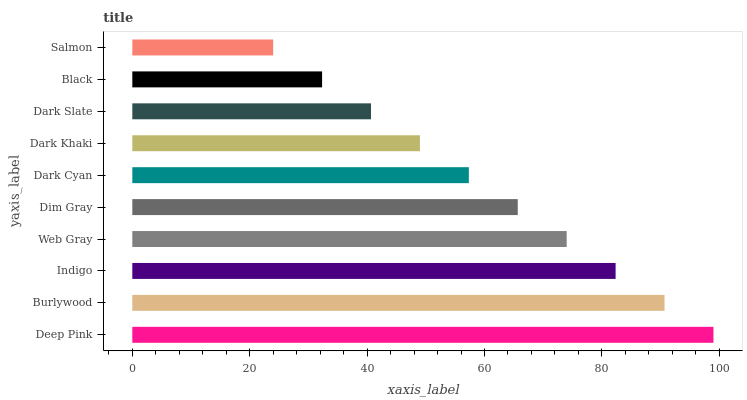Is Salmon the minimum?
Answer yes or no. Yes. Is Deep Pink the maximum?
Answer yes or no. Yes. Is Burlywood the minimum?
Answer yes or no. No. Is Burlywood the maximum?
Answer yes or no. No. Is Deep Pink greater than Burlywood?
Answer yes or no. Yes. Is Burlywood less than Deep Pink?
Answer yes or no. Yes. Is Burlywood greater than Deep Pink?
Answer yes or no. No. Is Deep Pink less than Burlywood?
Answer yes or no. No. Is Dim Gray the high median?
Answer yes or no. Yes. Is Dark Cyan the low median?
Answer yes or no. Yes. Is Deep Pink the high median?
Answer yes or no. No. Is Black the low median?
Answer yes or no. No. 